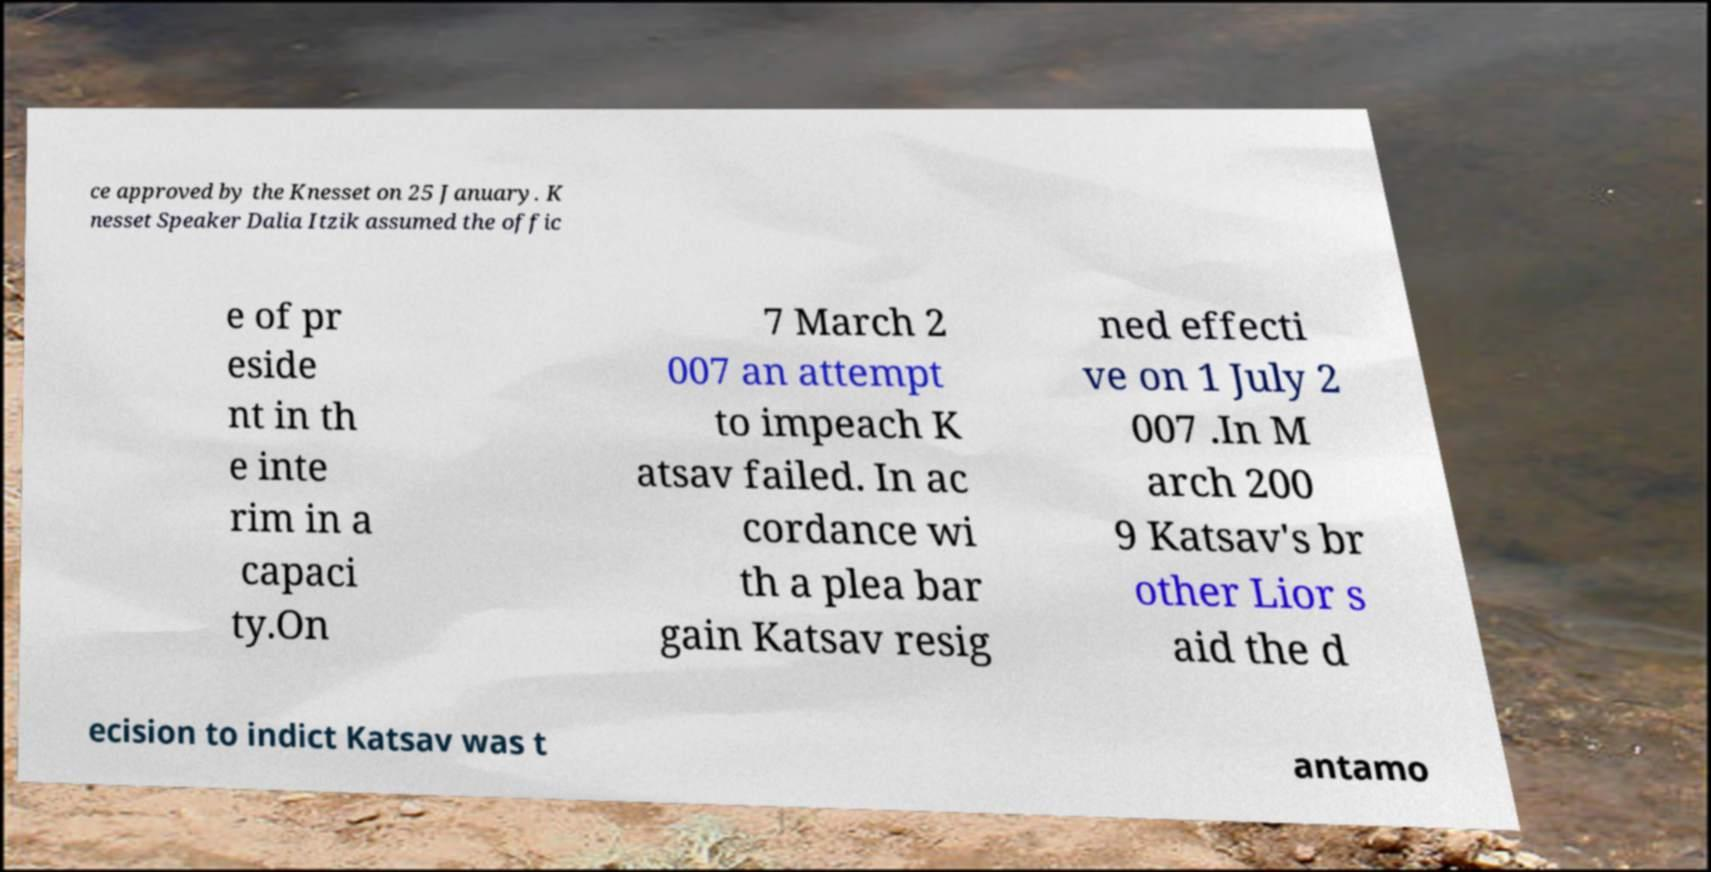Please read and relay the text visible in this image. What does it say? ce approved by the Knesset on 25 January. K nesset Speaker Dalia Itzik assumed the offic e of pr eside nt in th e inte rim in a capaci ty.On 7 March 2 007 an attempt to impeach K atsav failed. In ac cordance wi th a plea bar gain Katsav resig ned effecti ve on 1 July 2 007 .In M arch 200 9 Katsav's br other Lior s aid the d ecision to indict Katsav was t antamo 